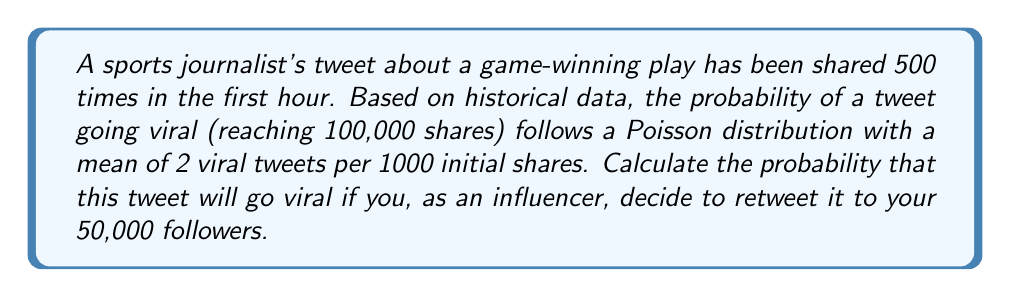Could you help me with this problem? Let's approach this step-by-step:

1) First, we need to calculate the lambda (λ) for our Poisson distribution:
   λ = (500 initial shares / 1000) * 2 viral tweets = 1

2) The probability of the tweet going viral without your retweet is given by the Poisson probability mass function:
   $$P(X = 1) = \frac{e^{-λ} * λ^1}{1!} = \frac{e^{-1} * 1^1}{1} = e^{-1} ≈ 0.3679$$

3) Now, let's consider your retweet. Assuming your 50,000 followers are unique and non-overlapping with the initial 500 shares, the new total potential reach is 50,500.

4) The new lambda (λ') for this expanded reach is:
   λ' = (50,500 / 1000) * 2 = 101

5) The new probability of the tweet going viral is:
   $$P(X ≥ 1) = 1 - P(X = 0) = 1 - \frac{e^{-λ'} * (λ')^0}{0!} = 1 - e^{-101} ≈ 1$$

6) Therefore, the probability of the tweet going viral after your retweet is effectively 1, or 100%.
Answer: $1$ (or 100%) 